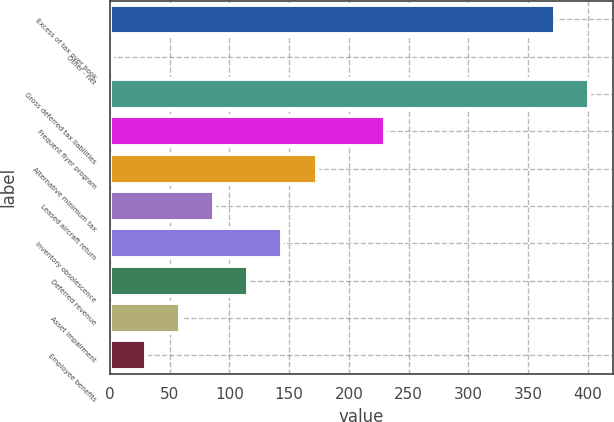Convert chart. <chart><loc_0><loc_0><loc_500><loc_500><bar_chart><fcel>Excess of tax over book<fcel>Other - net<fcel>Gross deferred tax liabilities<fcel>Frequent flyer program<fcel>Alternative minimum tax<fcel>Leased aircraft return<fcel>Inventory obsolescence<fcel>Deferred revenue<fcel>Asset impairment<fcel>Employee benefits<nl><fcel>372.43<fcel>1.8<fcel>400.94<fcel>229.88<fcel>172.86<fcel>87.33<fcel>144.35<fcel>115.84<fcel>58.82<fcel>30.31<nl></chart> 